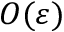Convert formula to latex. <formula><loc_0><loc_0><loc_500><loc_500>O ( \varepsilon )</formula> 